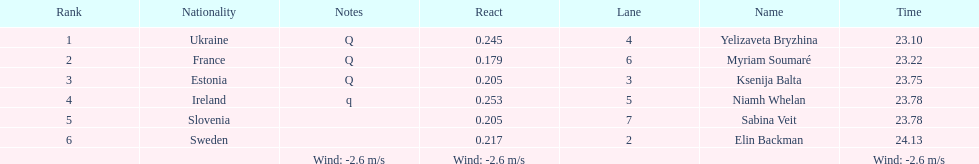Who is the first ranking player? Yelizaveta Bryzhina. 